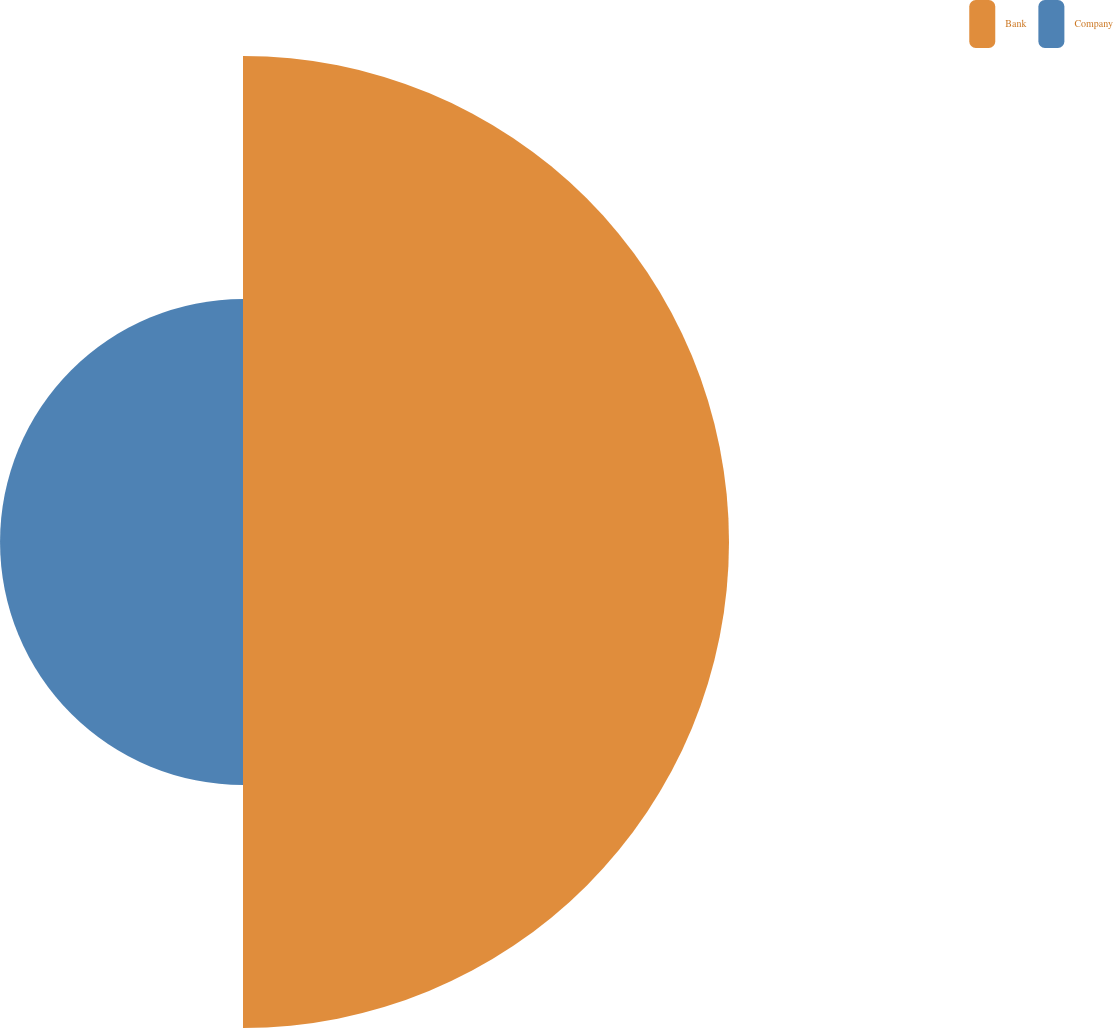Convert chart. <chart><loc_0><loc_0><loc_500><loc_500><pie_chart><fcel>Bank<fcel>Company<nl><fcel>66.67%<fcel>33.33%<nl></chart> 